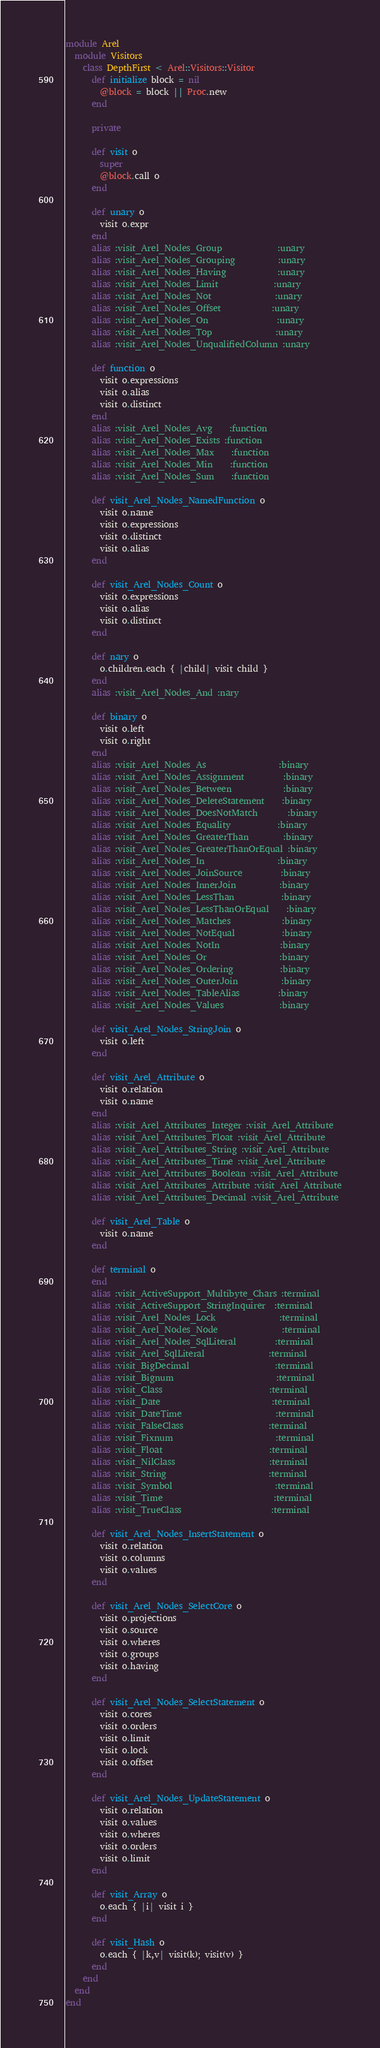<code> <loc_0><loc_0><loc_500><loc_500><_Ruby_>module Arel
  module Visitors
    class DepthFirst < Arel::Visitors::Visitor
      def initialize block = nil
        @block = block || Proc.new
      end

      private

      def visit o
        super
        @block.call o
      end

      def unary o
        visit o.expr
      end
      alias :visit_Arel_Nodes_Group             :unary
      alias :visit_Arel_Nodes_Grouping          :unary
      alias :visit_Arel_Nodes_Having            :unary
      alias :visit_Arel_Nodes_Limit             :unary
      alias :visit_Arel_Nodes_Not               :unary
      alias :visit_Arel_Nodes_Offset            :unary
      alias :visit_Arel_Nodes_On                :unary
      alias :visit_Arel_Nodes_Top               :unary
      alias :visit_Arel_Nodes_UnqualifiedColumn :unary

      def function o
        visit o.expressions
        visit o.alias
        visit o.distinct
      end
      alias :visit_Arel_Nodes_Avg    :function
      alias :visit_Arel_Nodes_Exists :function
      alias :visit_Arel_Nodes_Max    :function
      alias :visit_Arel_Nodes_Min    :function
      alias :visit_Arel_Nodes_Sum    :function

      def visit_Arel_Nodes_NamedFunction o
        visit o.name
        visit o.expressions
        visit o.distinct
        visit o.alias
      end

      def visit_Arel_Nodes_Count o
        visit o.expressions
        visit o.alias
        visit o.distinct
      end

      def nary o
        o.children.each { |child| visit child }
      end
      alias :visit_Arel_Nodes_And :nary

      def binary o
        visit o.left
        visit o.right
      end
      alias :visit_Arel_Nodes_As                 :binary
      alias :visit_Arel_Nodes_Assignment         :binary
      alias :visit_Arel_Nodes_Between            :binary
      alias :visit_Arel_Nodes_DeleteStatement    :binary
      alias :visit_Arel_Nodes_DoesNotMatch       :binary
      alias :visit_Arel_Nodes_Equality           :binary
      alias :visit_Arel_Nodes_GreaterThan        :binary
      alias :visit_Arel_Nodes_GreaterThanOrEqual :binary
      alias :visit_Arel_Nodes_In                 :binary
      alias :visit_Arel_Nodes_JoinSource         :binary
      alias :visit_Arel_Nodes_InnerJoin          :binary
      alias :visit_Arel_Nodes_LessThan           :binary
      alias :visit_Arel_Nodes_LessThanOrEqual    :binary
      alias :visit_Arel_Nodes_Matches            :binary
      alias :visit_Arel_Nodes_NotEqual           :binary
      alias :visit_Arel_Nodes_NotIn              :binary
      alias :visit_Arel_Nodes_Or                 :binary
      alias :visit_Arel_Nodes_Ordering           :binary
      alias :visit_Arel_Nodes_OuterJoin          :binary
      alias :visit_Arel_Nodes_TableAlias         :binary
      alias :visit_Arel_Nodes_Values             :binary

      def visit_Arel_Nodes_StringJoin o
        visit o.left
      end

      def visit_Arel_Attribute o
        visit o.relation
        visit o.name
      end
      alias :visit_Arel_Attributes_Integer :visit_Arel_Attribute
      alias :visit_Arel_Attributes_Float :visit_Arel_Attribute
      alias :visit_Arel_Attributes_String :visit_Arel_Attribute
      alias :visit_Arel_Attributes_Time :visit_Arel_Attribute
      alias :visit_Arel_Attributes_Boolean :visit_Arel_Attribute
      alias :visit_Arel_Attributes_Attribute :visit_Arel_Attribute
      alias :visit_Arel_Attributes_Decimal :visit_Arel_Attribute

      def visit_Arel_Table o
        visit o.name
      end

      def terminal o
      end
      alias :visit_ActiveSupport_Multibyte_Chars :terminal
      alias :visit_ActiveSupport_StringInquirer  :terminal
      alias :visit_Arel_Nodes_Lock               :terminal
      alias :visit_Arel_Nodes_Node               :terminal
      alias :visit_Arel_Nodes_SqlLiteral         :terminal
      alias :visit_Arel_SqlLiteral               :terminal
      alias :visit_BigDecimal                    :terminal
      alias :visit_Bignum                        :terminal
      alias :visit_Class                         :terminal
      alias :visit_Date                          :terminal
      alias :visit_DateTime                      :terminal
      alias :visit_FalseClass                    :terminal
      alias :visit_Fixnum                        :terminal
      alias :visit_Float                         :terminal
      alias :visit_NilClass                      :terminal
      alias :visit_String                        :terminal
      alias :visit_Symbol                        :terminal
      alias :visit_Time                          :terminal
      alias :visit_TrueClass                     :terminal

      def visit_Arel_Nodes_InsertStatement o
        visit o.relation
        visit o.columns
        visit o.values
      end

      def visit_Arel_Nodes_SelectCore o
        visit o.projections
        visit o.source
        visit o.wheres
        visit o.groups
        visit o.having
      end

      def visit_Arel_Nodes_SelectStatement o
        visit o.cores
        visit o.orders
        visit o.limit
        visit o.lock
        visit o.offset
      end

      def visit_Arel_Nodes_UpdateStatement o
        visit o.relation
        visit o.values
        visit o.wheres
        visit o.orders
        visit o.limit
      end

      def visit_Array o
        o.each { |i| visit i }
      end

      def visit_Hash o
        o.each { |k,v| visit(k); visit(v) }
      end
    end
  end
end
</code> 